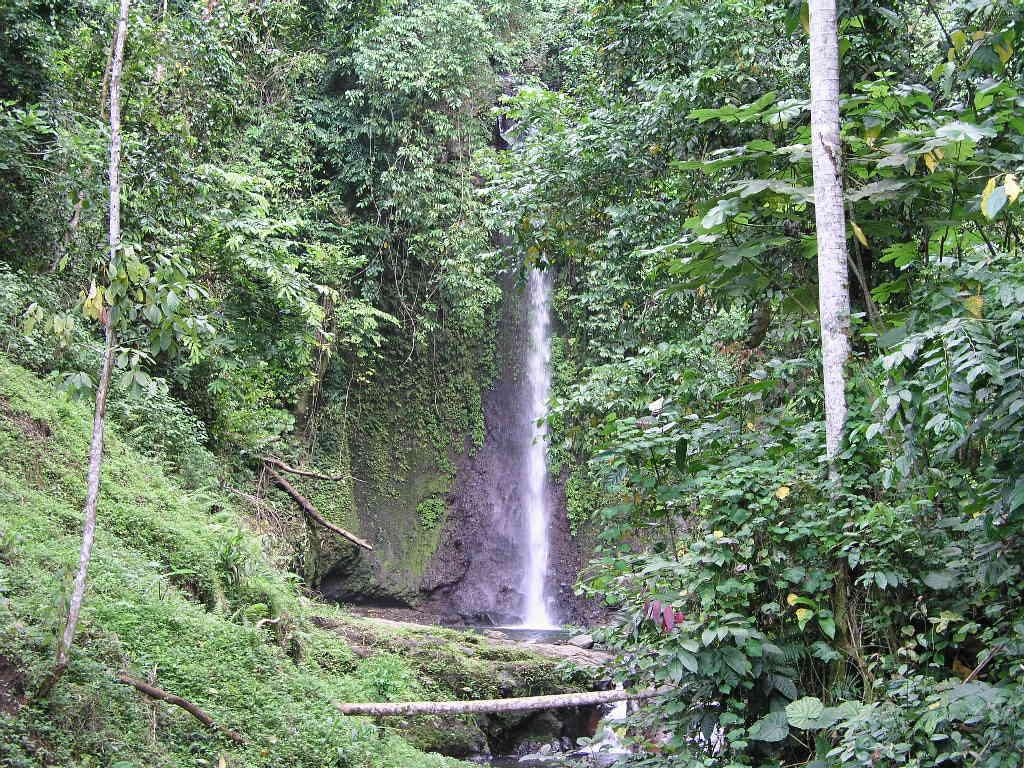What type of vegetation can be seen in the image? There is grass, plants, and trees in the image. What natural feature is present in the image? There is a waterfall in the image. What type of advertisement can be seen on the waterfall in the image? There is no advertisement present on the waterfall in the image. What pest is visible on the grass in the image? There are no pests visible on the grass in the image. 